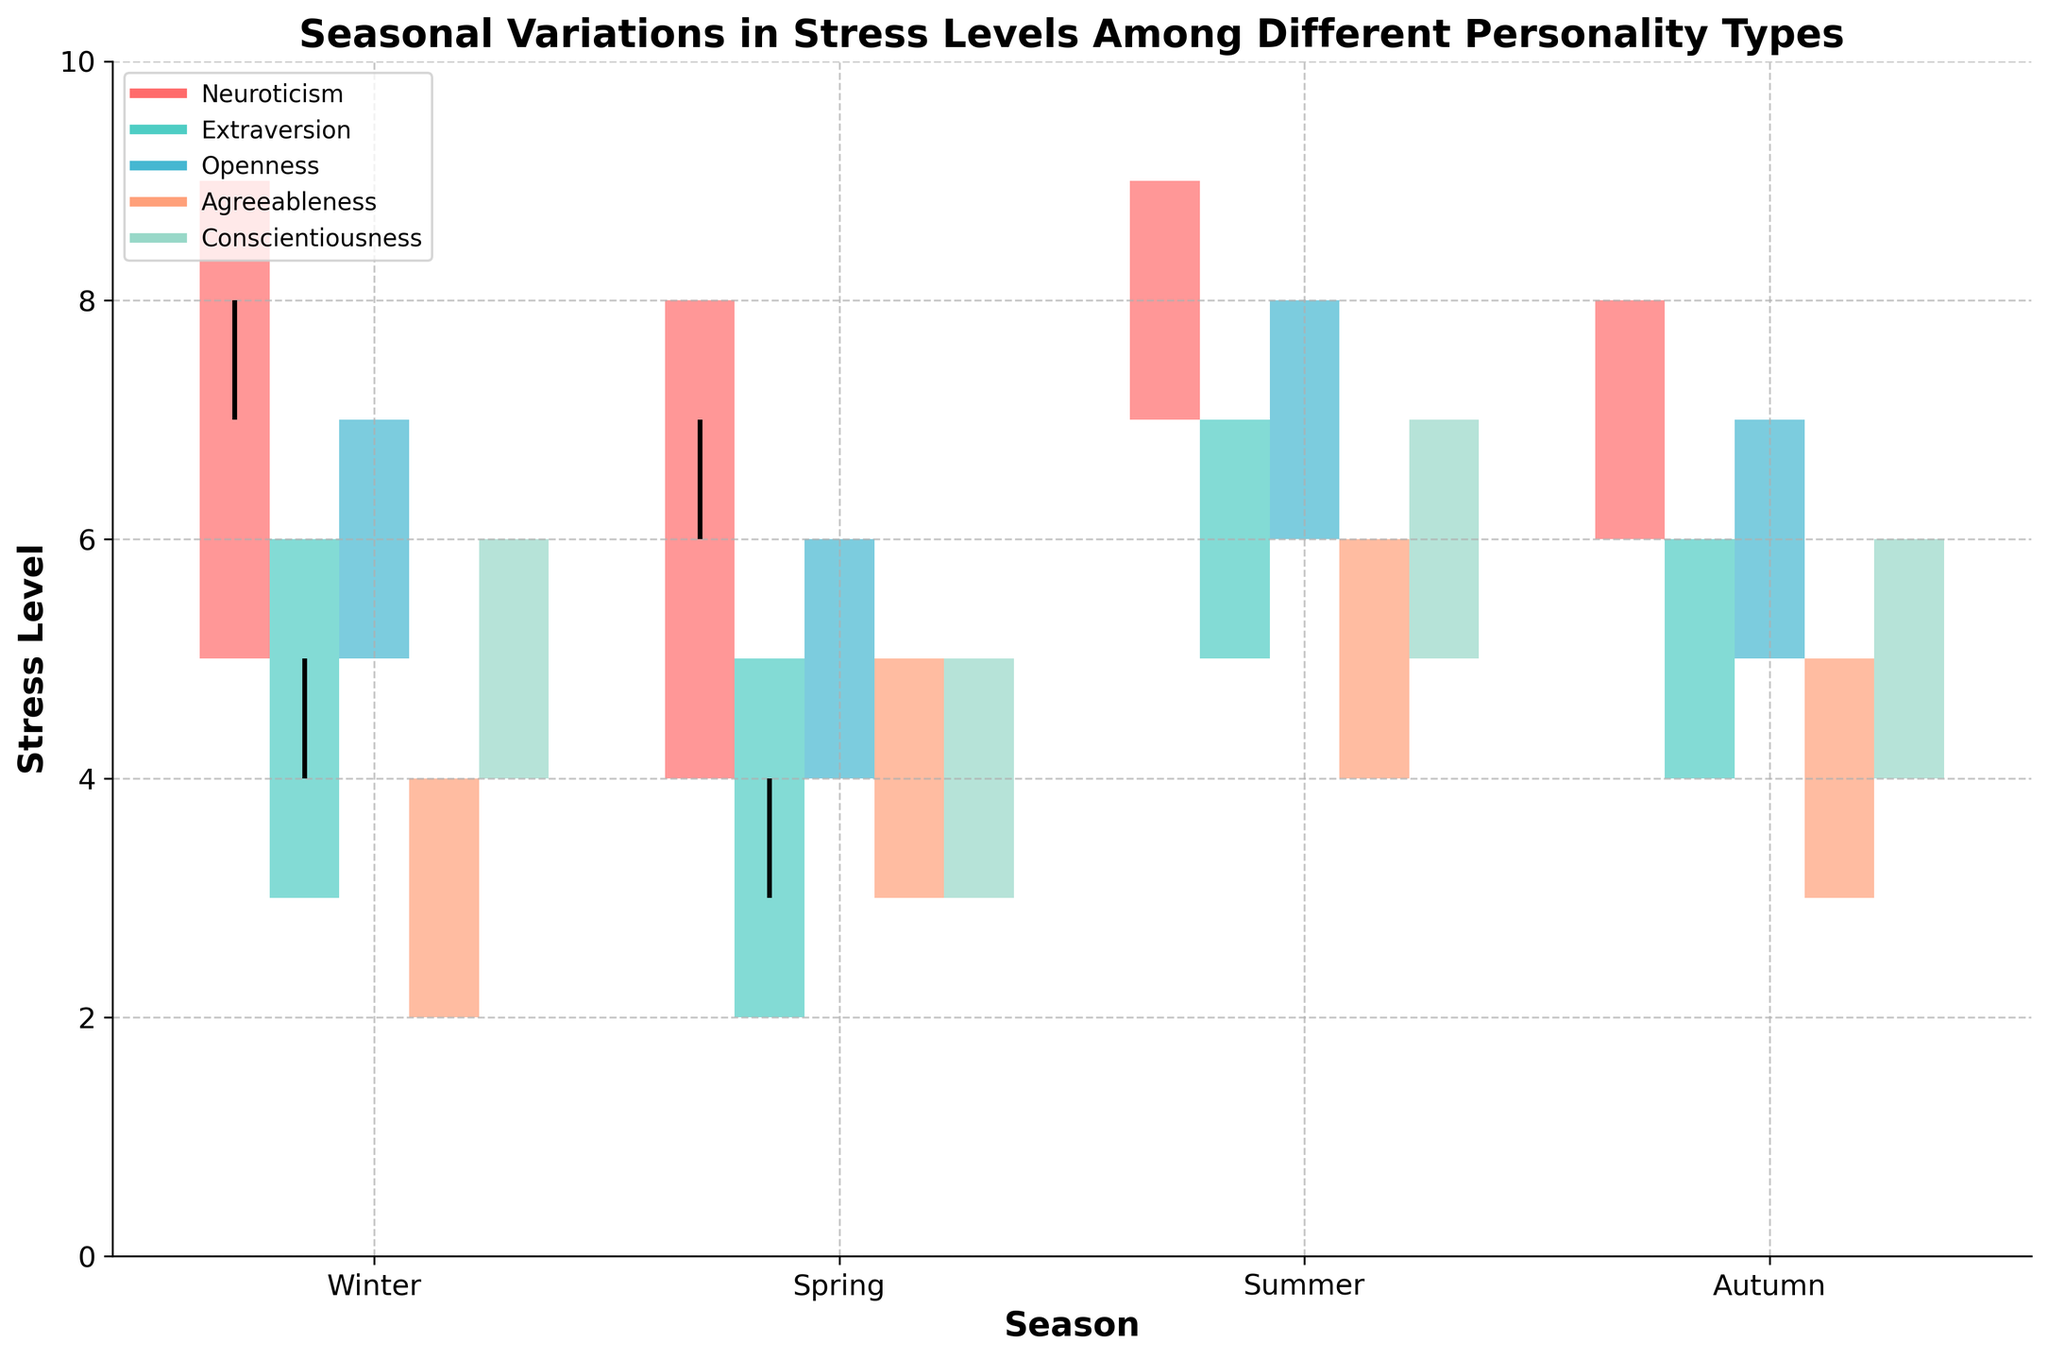Which season shows the highest stress levels for Neuroticism? The highest stress level for Neuroticism can be found by looking for the highest 'High' point in the candlestick plot for that personality type. In this case, that occurs in Summer, where the High value is 9.
Answer: Summer What is the range of stress levels for Extraversion in Spring? The range of stress levels is determined by subtracting the Low value from the High value for Extraversion in Spring. The High value is 5, and the Low value is 2, resulting in a range of 3.
Answer: 3 Which personality type shows the lowest stress level Close value in Autumn? To find the lowest stress level Close value in Autumn, look at the Close values for all personality types in that season. Agreeableness has the lowest Close value, which is 4.
Answer: Agreeableness What is the difference between the Open and Close stress levels for Conscientiousness in Winter? The difference can be determined by subtracting the Open value from the Close value for Conscientiousness in Winter. The Open value is 5 and the Close value is 5, resulting in a difference of 0.
Answer: 0 How does the stress level variability for Openness in Summer compare to Winter? The stress level variability is represented by the difference between the High and Low values for each season. For Openness in Summer, the High-Low difference is 8-6 = 2. For Winter, the difference is 7-5 = 2. Both have the same variability of 2.
Answer: Equal Which personality type experiences the least fluctuation in stress levels in Autumn? The fluctuation is determined by the range between the High and Low values. Comparing all personality types in Autumn, Conscientiousness has a High-Low difference of 6-4 = 2, which appears as the least fluctuation.
Answer: Conscientiousness What is the average Close value for Agreeableness across all seasons? To calculate the average Close value, sum all the Close values for Agreeableness and divide by the number of seasons. The values are 3 (Winter), 4 (Spring), 5 (Summer), and 4 (Autumn). (3 + 4 + 5 + 4) / 4 = 4.
Answer: 4 